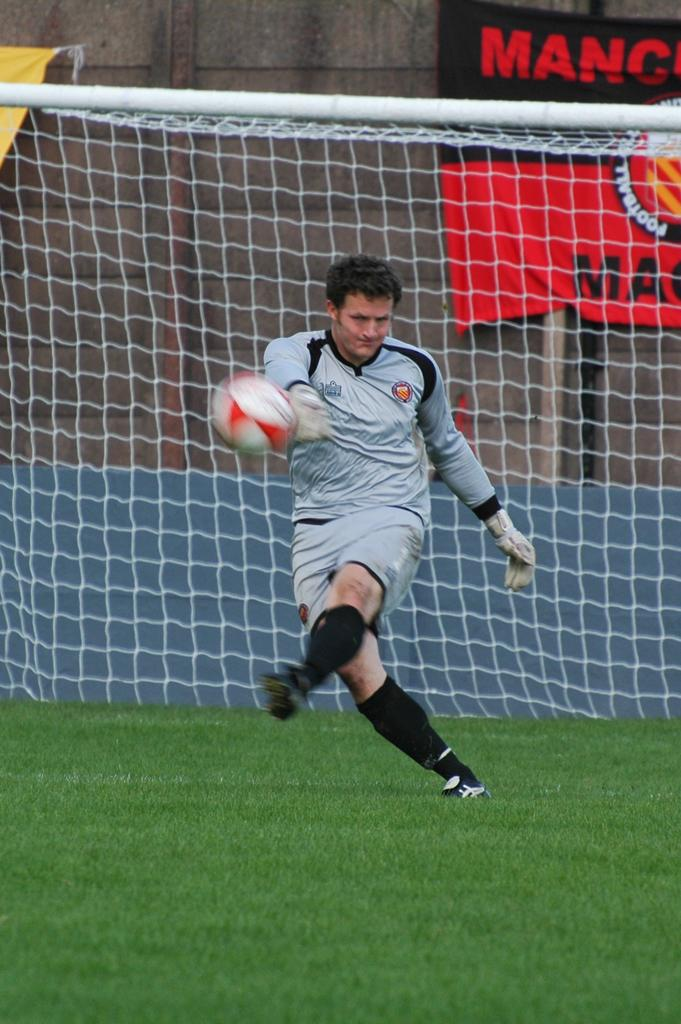What is the man in the image doing? The man is playing a game in the image. What object is the man playing with? The man is playing with a ball. What can be seen in the background of the image? There is a net, a wall, and flags in the background of the image. What type of surface is visible at the bottom of the image? There is grass at the bottom of the image. Can you see a needle being used by the man in the image? No, there is no needle present in the image. Is there a cow visible in the image? No, there is no cow present in the image. 